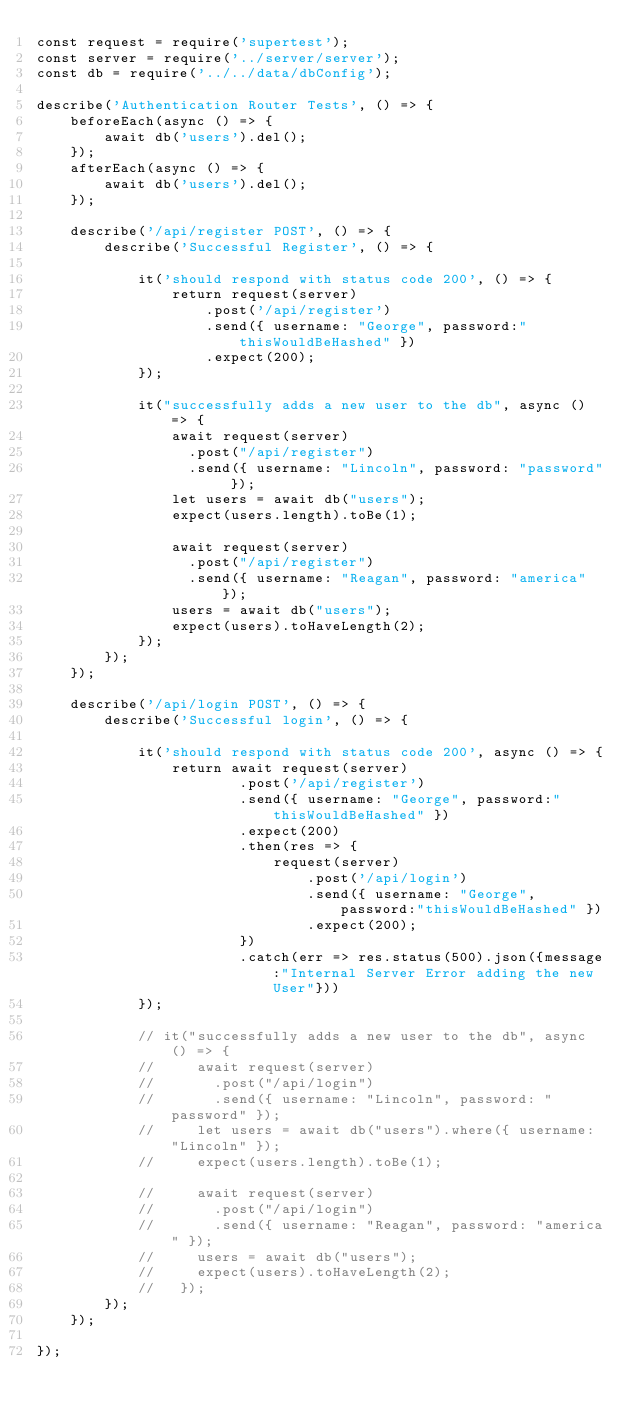<code> <loc_0><loc_0><loc_500><loc_500><_JavaScript_>const request = require('supertest');
const server = require('../server/server');
const db = require('../../data/dbConfig');

describe('Authentication Router Tests', () => {
    beforeEach(async () => {
        await db('users').del();
    });
    afterEach(async () => {
        await db('users').del();
    });

    describe('/api/register POST', () => {
        describe('Successful Register', () => {
            
            it('should respond with status code 200', () => {
                return request(server)
                    .post('/api/register')
                    .send({ username: "George", password:"thisWouldBeHashed" })
                    .expect(200);
            });
    
            it("successfully adds a new user to the db", async () => {
                await request(server)
                  .post("/api/register")
                  .send({ username: "Lincoln", password: "password" });
                let users = await db("users");
                expect(users.length).toBe(1);
          
                await request(server)
                  .post("/api/register")
                  .send({ username: "Reagan", password: "america" });
                users = await db("users");
                expect(users).toHaveLength(2);
            });
        });
    });

    describe('/api/login POST', () => {
        describe('Successful login', () => {
            
            it('should respond with status code 200', async () => {
                return await request(server)
                        .post('/api/register')
                        .send({ username: "George", password:"thisWouldBeHashed" })
                        .expect(200)
                        .then(res => {
                            request(server)
                                .post('/api/login')
                                .send({ username: "George", password:"thisWouldBeHashed" })
                                .expect(200);
                        })
                        .catch(err => res.status(500).json({message:"Internal Server Error adding the new User"}))       
            });
    
            // it("successfully adds a new user to the db", async () => {
            //     await request(server)
            //       .post("/api/login")
            //       .send({ username: "Lincoln", password: "password" });
            //     let users = await db("users").where({ username: "Lincoln" });
            //     expect(users.length).toBe(1);
          
            //     await request(server)
            //       .post("/api/login")
            //       .send({ username: "Reagan", password: "america" });
            //     users = await db("users");
            //     expect(users).toHaveLength(2);
            //   });
        });
    });

});</code> 